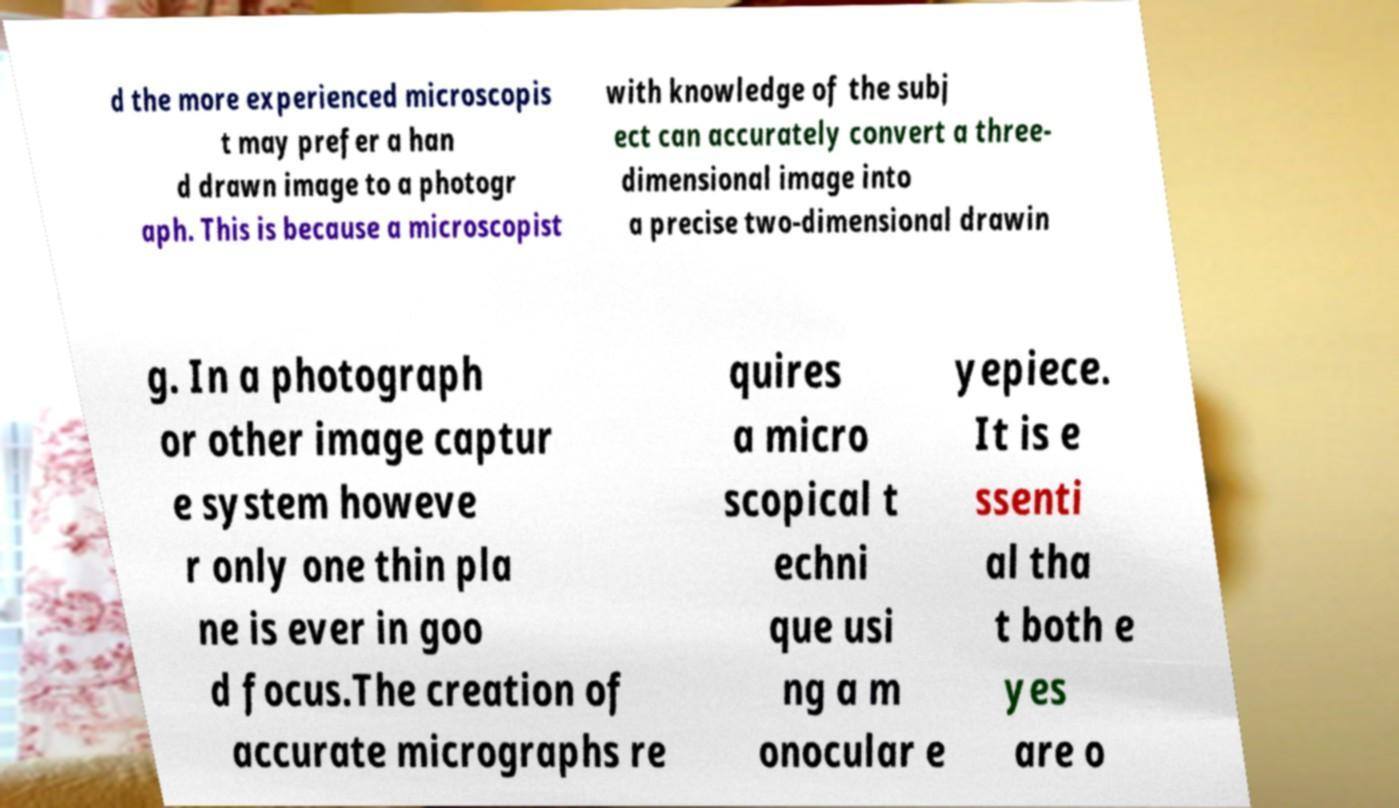There's text embedded in this image that I need extracted. Can you transcribe it verbatim? d the more experienced microscopis t may prefer a han d drawn image to a photogr aph. This is because a microscopist with knowledge of the subj ect can accurately convert a three- dimensional image into a precise two-dimensional drawin g. In a photograph or other image captur e system howeve r only one thin pla ne is ever in goo d focus.The creation of accurate micrographs re quires a micro scopical t echni que usi ng a m onocular e yepiece. It is e ssenti al tha t both e yes are o 